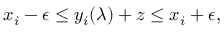<formula> <loc_0><loc_0><loc_500><loc_500>x _ { i } - \epsilon \leq y _ { i } ( \lambda ) + z \leq x _ { i } + \epsilon ,</formula> 